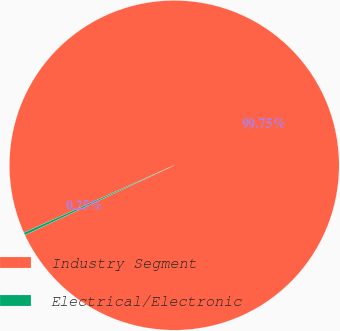<chart> <loc_0><loc_0><loc_500><loc_500><pie_chart><fcel>Industry Segment<fcel>Electrical/Electronic<nl><fcel>99.75%<fcel>0.25%<nl></chart> 